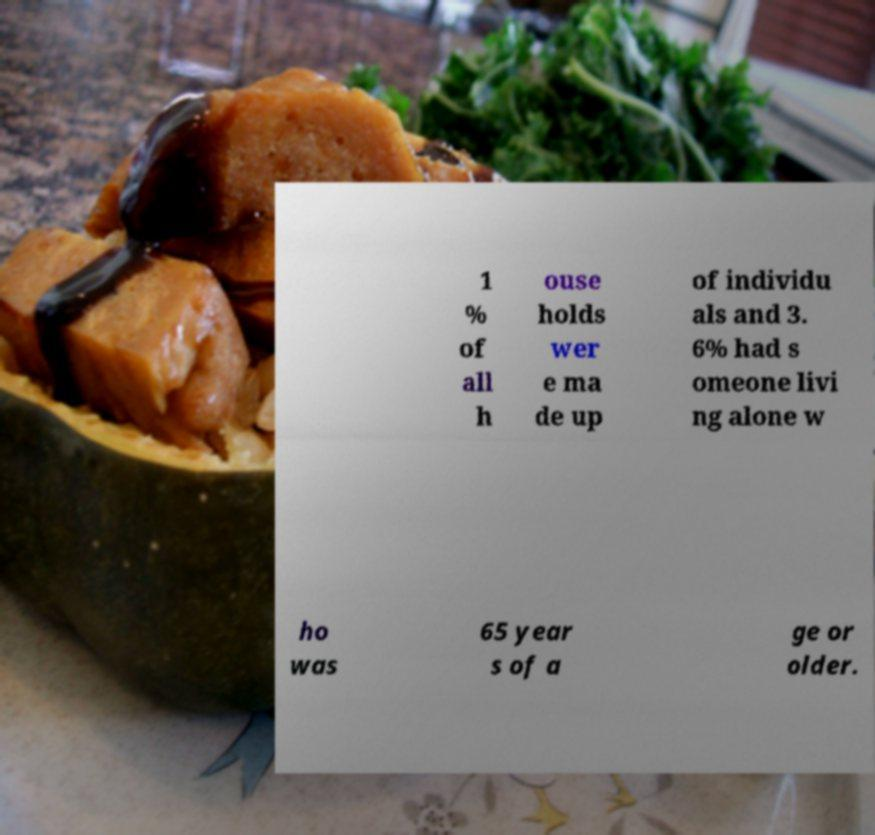Please read and relay the text visible in this image. What does it say? 1 % of all h ouse holds wer e ma de up of individu als and 3. 6% had s omeone livi ng alone w ho was 65 year s of a ge or older. 